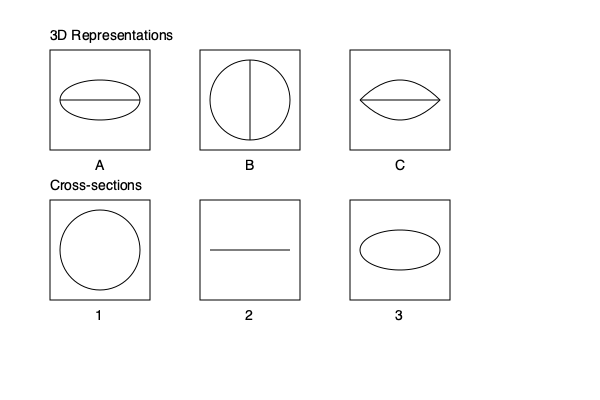Match the cross-sectional views (1, 2, 3) to their corresponding 3D representations (A, B, C) of surgical robotic components. Which combination is correct? To match the cross-sectional views with their 3D representations, we need to analyze each shape and visualize how it would appear when cut through its center:

1. Cross-section 1 shows a perfect circle. This corresponds to a 3D object that has a circular cross-section throughout its length. Looking at the 3D representations, object B has a circular profile when viewed from any angle perpendicular to its axis. Therefore, 1 matches with B.

2. Cross-section 2 shows a straight line. This indicates a 3D object that has a flat surface when cut through its center. Both A and C have horizontal lines in their 3D representations. However, object A has an elliptical profile, which would not result in a straight line cross-section. Object C, on the other hand, has a curved profile that, when cut horizontally through the center, would produce a straight line. Thus, 2 matches with C.

3. Cross-section 3 shows an ellipse. This corresponds to a 3D object that has an elliptical cross-section when cut through its center. Looking at the 3D representations, object A clearly shows an elliptical profile. Therefore, 3 matches with A.

By process of elimination and direct matching, we can conclude that the correct combination is:
1-B, 2-C, 3-A
Answer: 1-B, 2-C, 3-A 